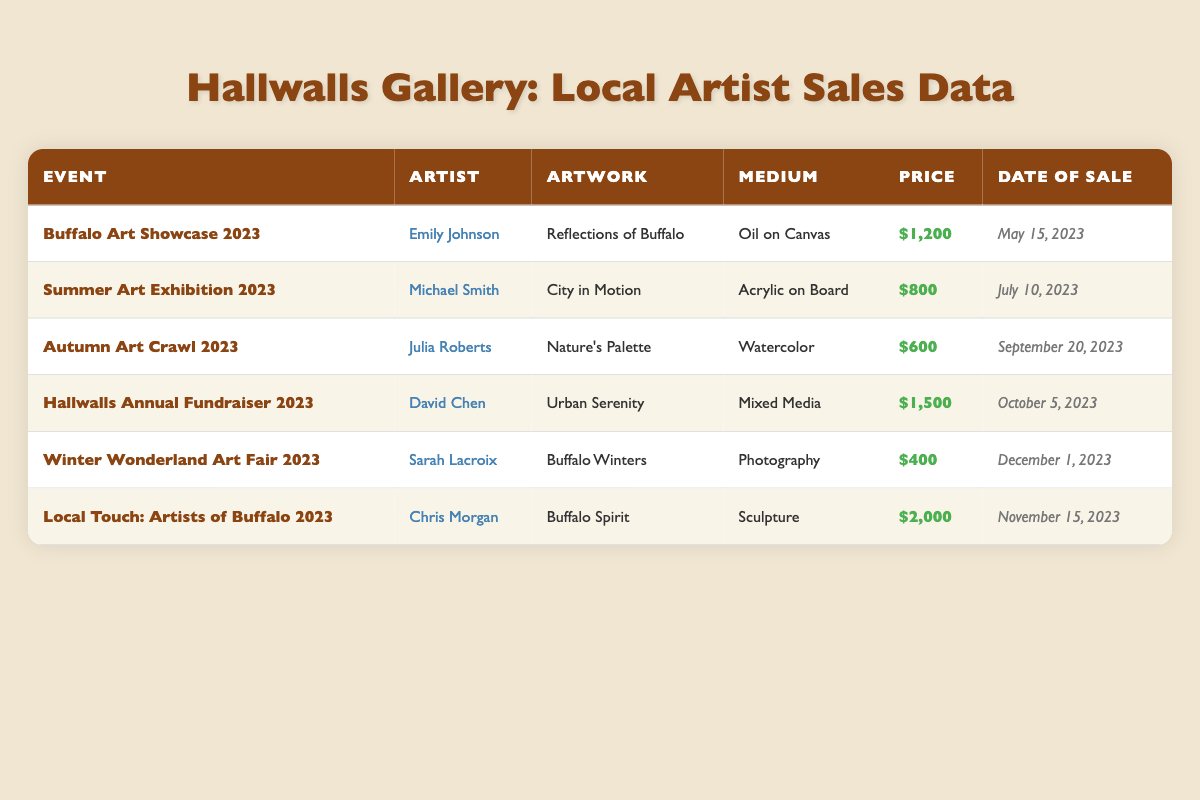What is the highest sale price in the table? The highest sale price can be identified by checking the 'Price' column in the table. The values are $1,200, $800, $600, $1,500, $400, and $2,000. Among these, $2,000 is the largest.
Answer: $2,000 How many artworks were sold for more than $1,000? To find the number of artworks sold for more than $1,000, we look at the sale prices: $1,200, $1,500, and $2,000. There are 3 artworks above this threshold.
Answer: 3 Which artist's work was sold at the Autumn Art Crawl 2023? By checking the 'Event' column for "Autumn Art Crawl 2023," we find the corresponding row lists "Julia Roberts" as the artist.
Answer: Julia Roberts What is the total sale price of all artworks sold? We calculate the total by summing all the sale prices: $1,200 + $800 + $600 + $1,500 + $400 + $2,000 = $6,500.
Answer: $6,500 Did Sarah Lacroix sell an artwork for more than $500? Looking at the row for Sarah Lacroix, the sale price for "Buffalo Winters" is $400, which is not more than $500, so the answer is no.
Answer: No What is the average price of the artworks sold? To find the average price, sum all the sale prices ($1,200 + $800 + $600 + $1,500 + $400 + $2,000 = $6,500) and divide by the number of artworks sold (6). The average price is $6,500 / 6 = $1,083.33.
Answer: $1,083.33 Which event had the lowest sale price, and what was that price? We check the 'Price' column and find that the lowest sale price listed is $400 from the "Winter Wonderland Art Fair 2023."
Answer: $400 How many different artists' works were sold at the Hallwalls Annual Fundraiser 2023? In the table, we see that only one artist's work, David Chen, was sold at this event, so the answer is one.
Answer: 1 Is there any artwork sold in the medium of photography? Searching the table for the 'Medium' column, we find "Photography" listed under Sarah Lacroix's artwork "Buffalo Winters," making it true that there is.
Answer: Yes 